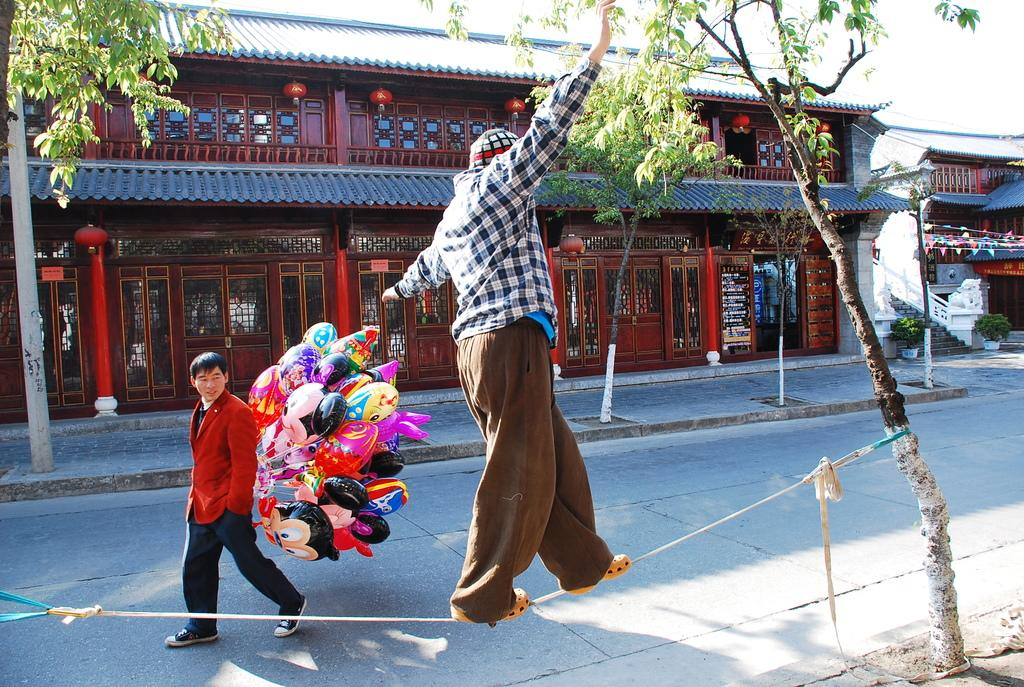What is the man in the image doing? The man is walking on a rope. What is the man holding while walking on the rope? The man is holding balloons. What can be seen in the foreground of the image? There is a tree visible in the image. What is visible in the background of the image? Buildings, trees, plants, and the sky are visible in the background of the image. What type of appliance is the man using to walk on the rope? There is no appliance present in the image; the man is simply walking on a rope. What is the man carrying in the crate while walking on the rope? There is no crate present in the image; the man is holding balloons. 